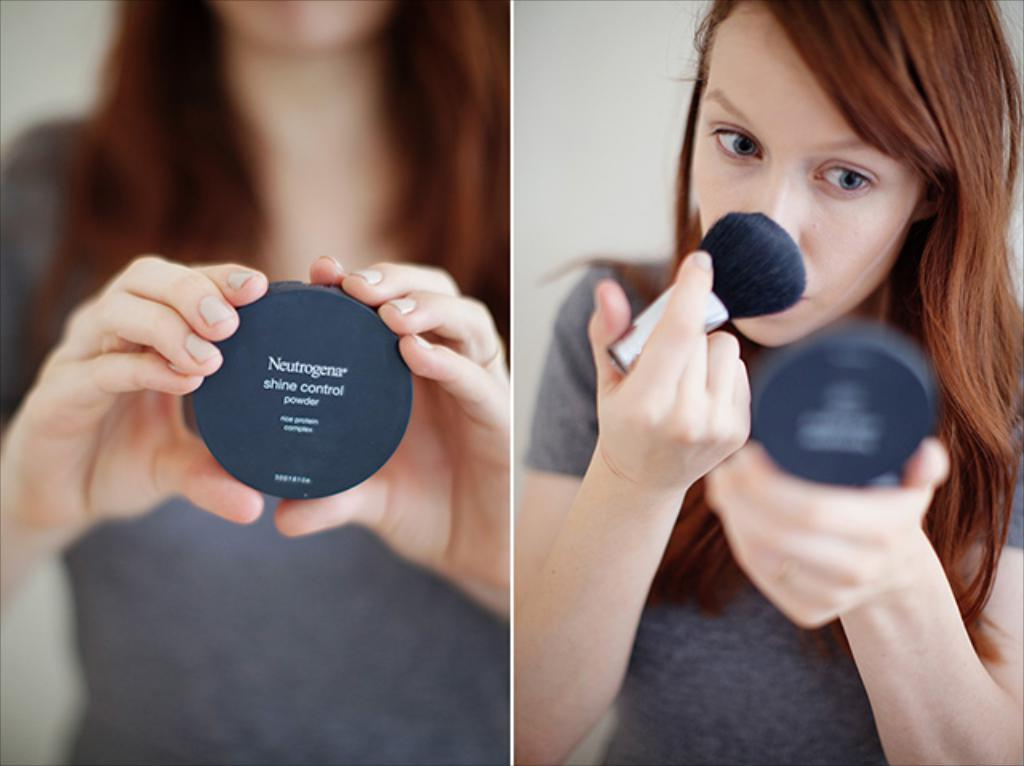<image>
Describe the image concisely. A woman applies some Neutrogena shine control powder to her nose. 